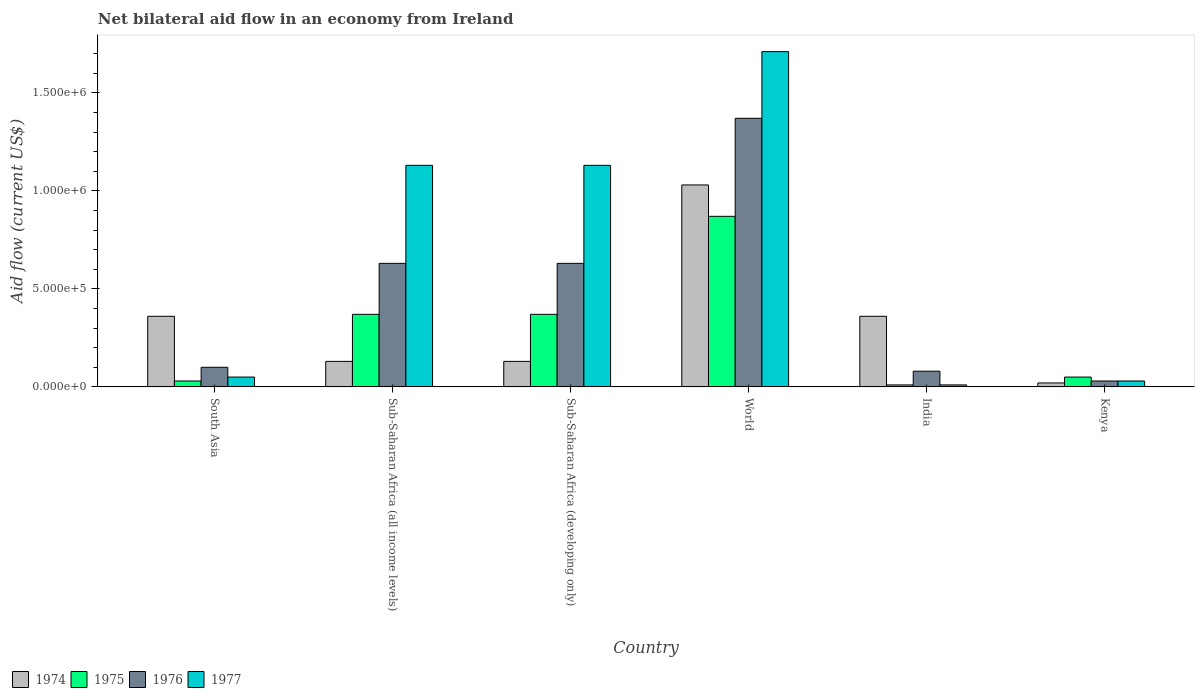How many groups of bars are there?
Provide a short and direct response. 6. Are the number of bars on each tick of the X-axis equal?
Your response must be concise. Yes. How many bars are there on the 2nd tick from the right?
Give a very brief answer. 4. What is the label of the 2nd group of bars from the left?
Give a very brief answer. Sub-Saharan Africa (all income levels). What is the net bilateral aid flow in 1977 in Sub-Saharan Africa (all income levels)?
Your response must be concise. 1.13e+06. Across all countries, what is the maximum net bilateral aid flow in 1977?
Make the answer very short. 1.71e+06. Across all countries, what is the minimum net bilateral aid flow in 1975?
Your response must be concise. 10000. In which country was the net bilateral aid flow in 1975 maximum?
Offer a terse response. World. In which country was the net bilateral aid flow in 1976 minimum?
Give a very brief answer. Kenya. What is the total net bilateral aid flow in 1976 in the graph?
Keep it short and to the point. 2.84e+06. What is the difference between the net bilateral aid flow in 1975 in India and that in Sub-Saharan Africa (developing only)?
Give a very brief answer. -3.60e+05. What is the difference between the net bilateral aid flow in 1974 in World and the net bilateral aid flow in 1976 in South Asia?
Your response must be concise. 9.30e+05. What is the average net bilateral aid flow in 1975 per country?
Give a very brief answer. 2.83e+05. What is the difference between the net bilateral aid flow of/in 1977 and net bilateral aid flow of/in 1974 in Kenya?
Keep it short and to the point. 10000. In how many countries, is the net bilateral aid flow in 1977 greater than 900000 US$?
Make the answer very short. 3. What is the ratio of the net bilateral aid flow in 1977 in Sub-Saharan Africa (developing only) to that in World?
Offer a very short reply. 0.66. Is the difference between the net bilateral aid flow in 1977 in India and Sub-Saharan Africa (all income levels) greater than the difference between the net bilateral aid flow in 1974 in India and Sub-Saharan Africa (all income levels)?
Make the answer very short. No. What is the difference between the highest and the lowest net bilateral aid flow in 1974?
Your answer should be very brief. 1.01e+06. Is the sum of the net bilateral aid flow in 1976 in Kenya and Sub-Saharan Africa (developing only) greater than the maximum net bilateral aid flow in 1977 across all countries?
Offer a terse response. No. Is it the case that in every country, the sum of the net bilateral aid flow in 1975 and net bilateral aid flow in 1977 is greater than the sum of net bilateral aid flow in 1974 and net bilateral aid flow in 1976?
Provide a short and direct response. No. What does the 1st bar from the left in Sub-Saharan Africa (all income levels) represents?
Provide a succinct answer. 1974. What does the 4th bar from the right in South Asia represents?
Offer a very short reply. 1974. Is it the case that in every country, the sum of the net bilateral aid flow in 1975 and net bilateral aid flow in 1977 is greater than the net bilateral aid flow in 1974?
Ensure brevity in your answer.  No. Are the values on the major ticks of Y-axis written in scientific E-notation?
Make the answer very short. Yes. Does the graph contain any zero values?
Offer a very short reply. No. How many legend labels are there?
Your answer should be very brief. 4. What is the title of the graph?
Keep it short and to the point. Net bilateral aid flow in an economy from Ireland. Does "1971" appear as one of the legend labels in the graph?
Keep it short and to the point. No. What is the label or title of the X-axis?
Offer a terse response. Country. What is the label or title of the Y-axis?
Ensure brevity in your answer.  Aid flow (current US$). What is the Aid flow (current US$) of 1975 in South Asia?
Offer a terse response. 3.00e+04. What is the Aid flow (current US$) in 1977 in South Asia?
Keep it short and to the point. 5.00e+04. What is the Aid flow (current US$) of 1975 in Sub-Saharan Africa (all income levels)?
Ensure brevity in your answer.  3.70e+05. What is the Aid flow (current US$) of 1976 in Sub-Saharan Africa (all income levels)?
Your response must be concise. 6.30e+05. What is the Aid flow (current US$) of 1977 in Sub-Saharan Africa (all income levels)?
Offer a very short reply. 1.13e+06. What is the Aid flow (current US$) in 1974 in Sub-Saharan Africa (developing only)?
Your answer should be compact. 1.30e+05. What is the Aid flow (current US$) of 1975 in Sub-Saharan Africa (developing only)?
Provide a short and direct response. 3.70e+05. What is the Aid flow (current US$) of 1976 in Sub-Saharan Africa (developing only)?
Your answer should be very brief. 6.30e+05. What is the Aid flow (current US$) of 1977 in Sub-Saharan Africa (developing only)?
Your response must be concise. 1.13e+06. What is the Aid flow (current US$) of 1974 in World?
Your response must be concise. 1.03e+06. What is the Aid flow (current US$) of 1975 in World?
Ensure brevity in your answer.  8.70e+05. What is the Aid flow (current US$) of 1976 in World?
Ensure brevity in your answer.  1.37e+06. What is the Aid flow (current US$) of 1977 in World?
Make the answer very short. 1.71e+06. What is the Aid flow (current US$) of 1974 in India?
Give a very brief answer. 3.60e+05. What is the Aid flow (current US$) in 1975 in India?
Provide a succinct answer. 10000. What is the Aid flow (current US$) of 1975 in Kenya?
Offer a very short reply. 5.00e+04. What is the Aid flow (current US$) in 1977 in Kenya?
Ensure brevity in your answer.  3.00e+04. Across all countries, what is the maximum Aid flow (current US$) in 1974?
Offer a terse response. 1.03e+06. Across all countries, what is the maximum Aid flow (current US$) in 1975?
Offer a terse response. 8.70e+05. Across all countries, what is the maximum Aid flow (current US$) of 1976?
Make the answer very short. 1.37e+06. Across all countries, what is the maximum Aid flow (current US$) of 1977?
Your answer should be compact. 1.71e+06. Across all countries, what is the minimum Aid flow (current US$) of 1976?
Give a very brief answer. 3.00e+04. Across all countries, what is the minimum Aid flow (current US$) in 1977?
Ensure brevity in your answer.  10000. What is the total Aid flow (current US$) in 1974 in the graph?
Provide a succinct answer. 2.03e+06. What is the total Aid flow (current US$) of 1975 in the graph?
Your response must be concise. 1.70e+06. What is the total Aid flow (current US$) of 1976 in the graph?
Keep it short and to the point. 2.84e+06. What is the total Aid flow (current US$) in 1977 in the graph?
Ensure brevity in your answer.  4.06e+06. What is the difference between the Aid flow (current US$) in 1974 in South Asia and that in Sub-Saharan Africa (all income levels)?
Your answer should be compact. 2.30e+05. What is the difference between the Aid flow (current US$) of 1976 in South Asia and that in Sub-Saharan Africa (all income levels)?
Make the answer very short. -5.30e+05. What is the difference between the Aid flow (current US$) in 1977 in South Asia and that in Sub-Saharan Africa (all income levels)?
Offer a very short reply. -1.08e+06. What is the difference between the Aid flow (current US$) of 1975 in South Asia and that in Sub-Saharan Africa (developing only)?
Make the answer very short. -3.40e+05. What is the difference between the Aid flow (current US$) in 1976 in South Asia and that in Sub-Saharan Africa (developing only)?
Your response must be concise. -5.30e+05. What is the difference between the Aid flow (current US$) in 1977 in South Asia and that in Sub-Saharan Africa (developing only)?
Provide a succinct answer. -1.08e+06. What is the difference between the Aid flow (current US$) in 1974 in South Asia and that in World?
Offer a terse response. -6.70e+05. What is the difference between the Aid flow (current US$) of 1975 in South Asia and that in World?
Provide a succinct answer. -8.40e+05. What is the difference between the Aid flow (current US$) in 1976 in South Asia and that in World?
Your response must be concise. -1.27e+06. What is the difference between the Aid flow (current US$) in 1977 in South Asia and that in World?
Provide a succinct answer. -1.66e+06. What is the difference between the Aid flow (current US$) in 1975 in South Asia and that in India?
Make the answer very short. 2.00e+04. What is the difference between the Aid flow (current US$) of 1976 in South Asia and that in India?
Your answer should be compact. 2.00e+04. What is the difference between the Aid flow (current US$) of 1977 in South Asia and that in India?
Offer a very short reply. 4.00e+04. What is the difference between the Aid flow (current US$) in 1974 in South Asia and that in Kenya?
Provide a succinct answer. 3.40e+05. What is the difference between the Aid flow (current US$) in 1975 in South Asia and that in Kenya?
Keep it short and to the point. -2.00e+04. What is the difference between the Aid flow (current US$) of 1976 in South Asia and that in Kenya?
Give a very brief answer. 7.00e+04. What is the difference between the Aid flow (current US$) of 1974 in Sub-Saharan Africa (all income levels) and that in Sub-Saharan Africa (developing only)?
Offer a very short reply. 0. What is the difference between the Aid flow (current US$) in 1975 in Sub-Saharan Africa (all income levels) and that in Sub-Saharan Africa (developing only)?
Ensure brevity in your answer.  0. What is the difference between the Aid flow (current US$) in 1977 in Sub-Saharan Africa (all income levels) and that in Sub-Saharan Africa (developing only)?
Ensure brevity in your answer.  0. What is the difference between the Aid flow (current US$) of 1974 in Sub-Saharan Africa (all income levels) and that in World?
Make the answer very short. -9.00e+05. What is the difference between the Aid flow (current US$) in 1975 in Sub-Saharan Africa (all income levels) and that in World?
Your answer should be very brief. -5.00e+05. What is the difference between the Aid flow (current US$) of 1976 in Sub-Saharan Africa (all income levels) and that in World?
Your response must be concise. -7.40e+05. What is the difference between the Aid flow (current US$) of 1977 in Sub-Saharan Africa (all income levels) and that in World?
Provide a short and direct response. -5.80e+05. What is the difference between the Aid flow (current US$) of 1974 in Sub-Saharan Africa (all income levels) and that in India?
Make the answer very short. -2.30e+05. What is the difference between the Aid flow (current US$) in 1977 in Sub-Saharan Africa (all income levels) and that in India?
Your answer should be very brief. 1.12e+06. What is the difference between the Aid flow (current US$) in 1977 in Sub-Saharan Africa (all income levels) and that in Kenya?
Provide a short and direct response. 1.10e+06. What is the difference between the Aid flow (current US$) of 1974 in Sub-Saharan Africa (developing only) and that in World?
Ensure brevity in your answer.  -9.00e+05. What is the difference between the Aid flow (current US$) in 1975 in Sub-Saharan Africa (developing only) and that in World?
Your answer should be very brief. -5.00e+05. What is the difference between the Aid flow (current US$) in 1976 in Sub-Saharan Africa (developing only) and that in World?
Provide a succinct answer. -7.40e+05. What is the difference between the Aid flow (current US$) in 1977 in Sub-Saharan Africa (developing only) and that in World?
Ensure brevity in your answer.  -5.80e+05. What is the difference between the Aid flow (current US$) of 1974 in Sub-Saharan Africa (developing only) and that in India?
Provide a succinct answer. -2.30e+05. What is the difference between the Aid flow (current US$) of 1975 in Sub-Saharan Africa (developing only) and that in India?
Give a very brief answer. 3.60e+05. What is the difference between the Aid flow (current US$) of 1976 in Sub-Saharan Africa (developing only) and that in India?
Your answer should be compact. 5.50e+05. What is the difference between the Aid flow (current US$) of 1977 in Sub-Saharan Africa (developing only) and that in India?
Offer a very short reply. 1.12e+06. What is the difference between the Aid flow (current US$) of 1974 in Sub-Saharan Africa (developing only) and that in Kenya?
Offer a terse response. 1.10e+05. What is the difference between the Aid flow (current US$) of 1976 in Sub-Saharan Africa (developing only) and that in Kenya?
Make the answer very short. 6.00e+05. What is the difference between the Aid flow (current US$) of 1977 in Sub-Saharan Africa (developing only) and that in Kenya?
Offer a terse response. 1.10e+06. What is the difference between the Aid flow (current US$) in 1974 in World and that in India?
Offer a very short reply. 6.70e+05. What is the difference between the Aid flow (current US$) of 1975 in World and that in India?
Provide a succinct answer. 8.60e+05. What is the difference between the Aid flow (current US$) of 1976 in World and that in India?
Provide a short and direct response. 1.29e+06. What is the difference between the Aid flow (current US$) in 1977 in World and that in India?
Your answer should be very brief. 1.70e+06. What is the difference between the Aid flow (current US$) of 1974 in World and that in Kenya?
Offer a terse response. 1.01e+06. What is the difference between the Aid flow (current US$) of 1975 in World and that in Kenya?
Provide a succinct answer. 8.20e+05. What is the difference between the Aid flow (current US$) in 1976 in World and that in Kenya?
Make the answer very short. 1.34e+06. What is the difference between the Aid flow (current US$) in 1977 in World and that in Kenya?
Your answer should be compact. 1.68e+06. What is the difference between the Aid flow (current US$) of 1974 in India and that in Kenya?
Make the answer very short. 3.40e+05. What is the difference between the Aid flow (current US$) in 1975 in India and that in Kenya?
Your answer should be very brief. -4.00e+04. What is the difference between the Aid flow (current US$) in 1976 in India and that in Kenya?
Offer a very short reply. 5.00e+04. What is the difference between the Aid flow (current US$) in 1977 in India and that in Kenya?
Your response must be concise. -2.00e+04. What is the difference between the Aid flow (current US$) of 1974 in South Asia and the Aid flow (current US$) of 1975 in Sub-Saharan Africa (all income levels)?
Your response must be concise. -10000. What is the difference between the Aid flow (current US$) in 1974 in South Asia and the Aid flow (current US$) in 1976 in Sub-Saharan Africa (all income levels)?
Keep it short and to the point. -2.70e+05. What is the difference between the Aid flow (current US$) in 1974 in South Asia and the Aid flow (current US$) in 1977 in Sub-Saharan Africa (all income levels)?
Your answer should be very brief. -7.70e+05. What is the difference between the Aid flow (current US$) in 1975 in South Asia and the Aid flow (current US$) in 1976 in Sub-Saharan Africa (all income levels)?
Your answer should be very brief. -6.00e+05. What is the difference between the Aid flow (current US$) in 1975 in South Asia and the Aid flow (current US$) in 1977 in Sub-Saharan Africa (all income levels)?
Make the answer very short. -1.10e+06. What is the difference between the Aid flow (current US$) in 1976 in South Asia and the Aid flow (current US$) in 1977 in Sub-Saharan Africa (all income levels)?
Ensure brevity in your answer.  -1.03e+06. What is the difference between the Aid flow (current US$) in 1974 in South Asia and the Aid flow (current US$) in 1976 in Sub-Saharan Africa (developing only)?
Your response must be concise. -2.70e+05. What is the difference between the Aid flow (current US$) in 1974 in South Asia and the Aid flow (current US$) in 1977 in Sub-Saharan Africa (developing only)?
Provide a succinct answer. -7.70e+05. What is the difference between the Aid flow (current US$) of 1975 in South Asia and the Aid flow (current US$) of 1976 in Sub-Saharan Africa (developing only)?
Your answer should be very brief. -6.00e+05. What is the difference between the Aid flow (current US$) of 1975 in South Asia and the Aid flow (current US$) of 1977 in Sub-Saharan Africa (developing only)?
Provide a short and direct response. -1.10e+06. What is the difference between the Aid flow (current US$) of 1976 in South Asia and the Aid flow (current US$) of 1977 in Sub-Saharan Africa (developing only)?
Your response must be concise. -1.03e+06. What is the difference between the Aid flow (current US$) of 1974 in South Asia and the Aid flow (current US$) of 1975 in World?
Your response must be concise. -5.10e+05. What is the difference between the Aid flow (current US$) of 1974 in South Asia and the Aid flow (current US$) of 1976 in World?
Offer a terse response. -1.01e+06. What is the difference between the Aid flow (current US$) in 1974 in South Asia and the Aid flow (current US$) in 1977 in World?
Offer a terse response. -1.35e+06. What is the difference between the Aid flow (current US$) of 1975 in South Asia and the Aid flow (current US$) of 1976 in World?
Offer a terse response. -1.34e+06. What is the difference between the Aid flow (current US$) in 1975 in South Asia and the Aid flow (current US$) in 1977 in World?
Ensure brevity in your answer.  -1.68e+06. What is the difference between the Aid flow (current US$) in 1976 in South Asia and the Aid flow (current US$) in 1977 in World?
Keep it short and to the point. -1.61e+06. What is the difference between the Aid flow (current US$) of 1975 in South Asia and the Aid flow (current US$) of 1977 in India?
Provide a succinct answer. 2.00e+04. What is the difference between the Aid flow (current US$) in 1976 in South Asia and the Aid flow (current US$) in 1977 in India?
Your answer should be very brief. 9.00e+04. What is the difference between the Aid flow (current US$) of 1974 in South Asia and the Aid flow (current US$) of 1976 in Kenya?
Ensure brevity in your answer.  3.30e+05. What is the difference between the Aid flow (current US$) in 1974 in South Asia and the Aid flow (current US$) in 1977 in Kenya?
Your answer should be very brief. 3.30e+05. What is the difference between the Aid flow (current US$) of 1976 in South Asia and the Aid flow (current US$) of 1977 in Kenya?
Ensure brevity in your answer.  7.00e+04. What is the difference between the Aid flow (current US$) of 1974 in Sub-Saharan Africa (all income levels) and the Aid flow (current US$) of 1975 in Sub-Saharan Africa (developing only)?
Provide a short and direct response. -2.40e+05. What is the difference between the Aid flow (current US$) of 1974 in Sub-Saharan Africa (all income levels) and the Aid flow (current US$) of 1976 in Sub-Saharan Africa (developing only)?
Your answer should be compact. -5.00e+05. What is the difference between the Aid flow (current US$) in 1975 in Sub-Saharan Africa (all income levels) and the Aid flow (current US$) in 1976 in Sub-Saharan Africa (developing only)?
Make the answer very short. -2.60e+05. What is the difference between the Aid flow (current US$) of 1975 in Sub-Saharan Africa (all income levels) and the Aid flow (current US$) of 1977 in Sub-Saharan Africa (developing only)?
Offer a terse response. -7.60e+05. What is the difference between the Aid flow (current US$) of 1976 in Sub-Saharan Africa (all income levels) and the Aid flow (current US$) of 1977 in Sub-Saharan Africa (developing only)?
Offer a very short reply. -5.00e+05. What is the difference between the Aid flow (current US$) of 1974 in Sub-Saharan Africa (all income levels) and the Aid flow (current US$) of 1975 in World?
Ensure brevity in your answer.  -7.40e+05. What is the difference between the Aid flow (current US$) of 1974 in Sub-Saharan Africa (all income levels) and the Aid flow (current US$) of 1976 in World?
Your answer should be compact. -1.24e+06. What is the difference between the Aid flow (current US$) in 1974 in Sub-Saharan Africa (all income levels) and the Aid flow (current US$) in 1977 in World?
Offer a very short reply. -1.58e+06. What is the difference between the Aid flow (current US$) in 1975 in Sub-Saharan Africa (all income levels) and the Aid flow (current US$) in 1976 in World?
Keep it short and to the point. -1.00e+06. What is the difference between the Aid flow (current US$) of 1975 in Sub-Saharan Africa (all income levels) and the Aid flow (current US$) of 1977 in World?
Your answer should be very brief. -1.34e+06. What is the difference between the Aid flow (current US$) in 1976 in Sub-Saharan Africa (all income levels) and the Aid flow (current US$) in 1977 in World?
Offer a terse response. -1.08e+06. What is the difference between the Aid flow (current US$) of 1974 in Sub-Saharan Africa (all income levels) and the Aid flow (current US$) of 1975 in India?
Your answer should be compact. 1.20e+05. What is the difference between the Aid flow (current US$) in 1974 in Sub-Saharan Africa (all income levels) and the Aid flow (current US$) in 1977 in India?
Your answer should be very brief. 1.20e+05. What is the difference between the Aid flow (current US$) of 1975 in Sub-Saharan Africa (all income levels) and the Aid flow (current US$) of 1976 in India?
Provide a succinct answer. 2.90e+05. What is the difference between the Aid flow (current US$) of 1975 in Sub-Saharan Africa (all income levels) and the Aid flow (current US$) of 1977 in India?
Your response must be concise. 3.60e+05. What is the difference between the Aid flow (current US$) in 1976 in Sub-Saharan Africa (all income levels) and the Aid flow (current US$) in 1977 in India?
Keep it short and to the point. 6.20e+05. What is the difference between the Aid flow (current US$) in 1974 in Sub-Saharan Africa (all income levels) and the Aid flow (current US$) in 1976 in Kenya?
Provide a succinct answer. 1.00e+05. What is the difference between the Aid flow (current US$) in 1975 in Sub-Saharan Africa (all income levels) and the Aid flow (current US$) in 1976 in Kenya?
Make the answer very short. 3.40e+05. What is the difference between the Aid flow (current US$) of 1976 in Sub-Saharan Africa (all income levels) and the Aid flow (current US$) of 1977 in Kenya?
Make the answer very short. 6.00e+05. What is the difference between the Aid flow (current US$) in 1974 in Sub-Saharan Africa (developing only) and the Aid flow (current US$) in 1975 in World?
Make the answer very short. -7.40e+05. What is the difference between the Aid flow (current US$) in 1974 in Sub-Saharan Africa (developing only) and the Aid flow (current US$) in 1976 in World?
Your answer should be very brief. -1.24e+06. What is the difference between the Aid flow (current US$) of 1974 in Sub-Saharan Africa (developing only) and the Aid flow (current US$) of 1977 in World?
Provide a short and direct response. -1.58e+06. What is the difference between the Aid flow (current US$) in 1975 in Sub-Saharan Africa (developing only) and the Aid flow (current US$) in 1976 in World?
Offer a terse response. -1.00e+06. What is the difference between the Aid flow (current US$) of 1975 in Sub-Saharan Africa (developing only) and the Aid flow (current US$) of 1977 in World?
Make the answer very short. -1.34e+06. What is the difference between the Aid flow (current US$) of 1976 in Sub-Saharan Africa (developing only) and the Aid flow (current US$) of 1977 in World?
Your answer should be very brief. -1.08e+06. What is the difference between the Aid flow (current US$) of 1974 in Sub-Saharan Africa (developing only) and the Aid flow (current US$) of 1975 in India?
Provide a short and direct response. 1.20e+05. What is the difference between the Aid flow (current US$) in 1974 in Sub-Saharan Africa (developing only) and the Aid flow (current US$) in 1976 in India?
Make the answer very short. 5.00e+04. What is the difference between the Aid flow (current US$) of 1975 in Sub-Saharan Africa (developing only) and the Aid flow (current US$) of 1976 in India?
Provide a short and direct response. 2.90e+05. What is the difference between the Aid flow (current US$) of 1976 in Sub-Saharan Africa (developing only) and the Aid flow (current US$) of 1977 in India?
Provide a succinct answer. 6.20e+05. What is the difference between the Aid flow (current US$) in 1974 in Sub-Saharan Africa (developing only) and the Aid flow (current US$) in 1976 in Kenya?
Provide a succinct answer. 1.00e+05. What is the difference between the Aid flow (current US$) in 1974 in Sub-Saharan Africa (developing only) and the Aid flow (current US$) in 1977 in Kenya?
Your response must be concise. 1.00e+05. What is the difference between the Aid flow (current US$) in 1974 in World and the Aid flow (current US$) in 1975 in India?
Offer a very short reply. 1.02e+06. What is the difference between the Aid flow (current US$) of 1974 in World and the Aid flow (current US$) of 1976 in India?
Provide a succinct answer. 9.50e+05. What is the difference between the Aid flow (current US$) of 1974 in World and the Aid flow (current US$) of 1977 in India?
Provide a short and direct response. 1.02e+06. What is the difference between the Aid flow (current US$) in 1975 in World and the Aid flow (current US$) in 1976 in India?
Your answer should be very brief. 7.90e+05. What is the difference between the Aid flow (current US$) of 1975 in World and the Aid flow (current US$) of 1977 in India?
Offer a very short reply. 8.60e+05. What is the difference between the Aid flow (current US$) in 1976 in World and the Aid flow (current US$) in 1977 in India?
Provide a short and direct response. 1.36e+06. What is the difference between the Aid flow (current US$) of 1974 in World and the Aid flow (current US$) of 1975 in Kenya?
Your answer should be compact. 9.80e+05. What is the difference between the Aid flow (current US$) of 1974 in World and the Aid flow (current US$) of 1976 in Kenya?
Offer a terse response. 1.00e+06. What is the difference between the Aid flow (current US$) in 1974 in World and the Aid flow (current US$) in 1977 in Kenya?
Ensure brevity in your answer.  1.00e+06. What is the difference between the Aid flow (current US$) in 1975 in World and the Aid flow (current US$) in 1976 in Kenya?
Your answer should be compact. 8.40e+05. What is the difference between the Aid flow (current US$) of 1975 in World and the Aid flow (current US$) of 1977 in Kenya?
Your answer should be very brief. 8.40e+05. What is the difference between the Aid flow (current US$) in 1976 in World and the Aid flow (current US$) in 1977 in Kenya?
Provide a succinct answer. 1.34e+06. What is the difference between the Aid flow (current US$) of 1974 in India and the Aid flow (current US$) of 1975 in Kenya?
Ensure brevity in your answer.  3.10e+05. What is the difference between the Aid flow (current US$) of 1974 in India and the Aid flow (current US$) of 1976 in Kenya?
Offer a terse response. 3.30e+05. What is the difference between the Aid flow (current US$) in 1974 in India and the Aid flow (current US$) in 1977 in Kenya?
Keep it short and to the point. 3.30e+05. What is the difference between the Aid flow (current US$) in 1975 in India and the Aid flow (current US$) in 1976 in Kenya?
Offer a very short reply. -2.00e+04. What is the average Aid flow (current US$) in 1974 per country?
Your answer should be very brief. 3.38e+05. What is the average Aid flow (current US$) of 1975 per country?
Your response must be concise. 2.83e+05. What is the average Aid flow (current US$) of 1976 per country?
Your answer should be compact. 4.73e+05. What is the average Aid flow (current US$) in 1977 per country?
Provide a succinct answer. 6.77e+05. What is the difference between the Aid flow (current US$) in 1974 and Aid flow (current US$) in 1975 in South Asia?
Keep it short and to the point. 3.30e+05. What is the difference between the Aid flow (current US$) of 1974 and Aid flow (current US$) of 1977 in South Asia?
Your response must be concise. 3.10e+05. What is the difference between the Aid flow (current US$) in 1975 and Aid flow (current US$) in 1977 in South Asia?
Provide a succinct answer. -2.00e+04. What is the difference between the Aid flow (current US$) in 1976 and Aid flow (current US$) in 1977 in South Asia?
Give a very brief answer. 5.00e+04. What is the difference between the Aid flow (current US$) in 1974 and Aid flow (current US$) in 1975 in Sub-Saharan Africa (all income levels)?
Offer a terse response. -2.40e+05. What is the difference between the Aid flow (current US$) of 1974 and Aid flow (current US$) of 1976 in Sub-Saharan Africa (all income levels)?
Make the answer very short. -5.00e+05. What is the difference between the Aid flow (current US$) in 1974 and Aid flow (current US$) in 1977 in Sub-Saharan Africa (all income levels)?
Keep it short and to the point. -1.00e+06. What is the difference between the Aid flow (current US$) in 1975 and Aid flow (current US$) in 1976 in Sub-Saharan Africa (all income levels)?
Make the answer very short. -2.60e+05. What is the difference between the Aid flow (current US$) of 1975 and Aid flow (current US$) of 1977 in Sub-Saharan Africa (all income levels)?
Your response must be concise. -7.60e+05. What is the difference between the Aid flow (current US$) in 1976 and Aid flow (current US$) in 1977 in Sub-Saharan Africa (all income levels)?
Keep it short and to the point. -5.00e+05. What is the difference between the Aid flow (current US$) of 1974 and Aid flow (current US$) of 1976 in Sub-Saharan Africa (developing only)?
Keep it short and to the point. -5.00e+05. What is the difference between the Aid flow (current US$) in 1974 and Aid flow (current US$) in 1977 in Sub-Saharan Africa (developing only)?
Make the answer very short. -1.00e+06. What is the difference between the Aid flow (current US$) of 1975 and Aid flow (current US$) of 1977 in Sub-Saharan Africa (developing only)?
Offer a terse response. -7.60e+05. What is the difference between the Aid flow (current US$) in 1976 and Aid flow (current US$) in 1977 in Sub-Saharan Africa (developing only)?
Ensure brevity in your answer.  -5.00e+05. What is the difference between the Aid flow (current US$) of 1974 and Aid flow (current US$) of 1977 in World?
Make the answer very short. -6.80e+05. What is the difference between the Aid flow (current US$) in 1975 and Aid flow (current US$) in 1976 in World?
Keep it short and to the point. -5.00e+05. What is the difference between the Aid flow (current US$) of 1975 and Aid flow (current US$) of 1977 in World?
Make the answer very short. -8.40e+05. What is the difference between the Aid flow (current US$) of 1974 and Aid flow (current US$) of 1975 in India?
Give a very brief answer. 3.50e+05. What is the difference between the Aid flow (current US$) in 1974 and Aid flow (current US$) in 1977 in India?
Ensure brevity in your answer.  3.50e+05. What is the difference between the Aid flow (current US$) of 1975 and Aid flow (current US$) of 1976 in India?
Ensure brevity in your answer.  -7.00e+04. What is the difference between the Aid flow (current US$) in 1974 and Aid flow (current US$) in 1976 in Kenya?
Keep it short and to the point. -10000. What is the difference between the Aid flow (current US$) of 1974 and Aid flow (current US$) of 1977 in Kenya?
Your answer should be very brief. -10000. What is the ratio of the Aid flow (current US$) of 1974 in South Asia to that in Sub-Saharan Africa (all income levels)?
Keep it short and to the point. 2.77. What is the ratio of the Aid flow (current US$) of 1975 in South Asia to that in Sub-Saharan Africa (all income levels)?
Provide a short and direct response. 0.08. What is the ratio of the Aid flow (current US$) in 1976 in South Asia to that in Sub-Saharan Africa (all income levels)?
Provide a succinct answer. 0.16. What is the ratio of the Aid flow (current US$) of 1977 in South Asia to that in Sub-Saharan Africa (all income levels)?
Your answer should be very brief. 0.04. What is the ratio of the Aid flow (current US$) in 1974 in South Asia to that in Sub-Saharan Africa (developing only)?
Give a very brief answer. 2.77. What is the ratio of the Aid flow (current US$) in 1975 in South Asia to that in Sub-Saharan Africa (developing only)?
Provide a short and direct response. 0.08. What is the ratio of the Aid flow (current US$) of 1976 in South Asia to that in Sub-Saharan Africa (developing only)?
Ensure brevity in your answer.  0.16. What is the ratio of the Aid flow (current US$) in 1977 in South Asia to that in Sub-Saharan Africa (developing only)?
Offer a terse response. 0.04. What is the ratio of the Aid flow (current US$) of 1974 in South Asia to that in World?
Offer a very short reply. 0.35. What is the ratio of the Aid flow (current US$) in 1975 in South Asia to that in World?
Provide a succinct answer. 0.03. What is the ratio of the Aid flow (current US$) in 1976 in South Asia to that in World?
Provide a succinct answer. 0.07. What is the ratio of the Aid flow (current US$) in 1977 in South Asia to that in World?
Your answer should be very brief. 0.03. What is the ratio of the Aid flow (current US$) in 1975 in South Asia to that in India?
Make the answer very short. 3. What is the ratio of the Aid flow (current US$) of 1976 in South Asia to that in Kenya?
Provide a succinct answer. 3.33. What is the ratio of the Aid flow (current US$) in 1977 in South Asia to that in Kenya?
Offer a very short reply. 1.67. What is the ratio of the Aid flow (current US$) of 1974 in Sub-Saharan Africa (all income levels) to that in Sub-Saharan Africa (developing only)?
Give a very brief answer. 1. What is the ratio of the Aid flow (current US$) of 1975 in Sub-Saharan Africa (all income levels) to that in Sub-Saharan Africa (developing only)?
Offer a very short reply. 1. What is the ratio of the Aid flow (current US$) in 1976 in Sub-Saharan Africa (all income levels) to that in Sub-Saharan Africa (developing only)?
Your answer should be compact. 1. What is the ratio of the Aid flow (current US$) of 1977 in Sub-Saharan Africa (all income levels) to that in Sub-Saharan Africa (developing only)?
Give a very brief answer. 1. What is the ratio of the Aid flow (current US$) of 1974 in Sub-Saharan Africa (all income levels) to that in World?
Your answer should be compact. 0.13. What is the ratio of the Aid flow (current US$) of 1975 in Sub-Saharan Africa (all income levels) to that in World?
Your answer should be compact. 0.43. What is the ratio of the Aid flow (current US$) in 1976 in Sub-Saharan Africa (all income levels) to that in World?
Your response must be concise. 0.46. What is the ratio of the Aid flow (current US$) in 1977 in Sub-Saharan Africa (all income levels) to that in World?
Your answer should be very brief. 0.66. What is the ratio of the Aid flow (current US$) in 1974 in Sub-Saharan Africa (all income levels) to that in India?
Keep it short and to the point. 0.36. What is the ratio of the Aid flow (current US$) in 1976 in Sub-Saharan Africa (all income levels) to that in India?
Give a very brief answer. 7.88. What is the ratio of the Aid flow (current US$) of 1977 in Sub-Saharan Africa (all income levels) to that in India?
Ensure brevity in your answer.  113. What is the ratio of the Aid flow (current US$) of 1974 in Sub-Saharan Africa (all income levels) to that in Kenya?
Keep it short and to the point. 6.5. What is the ratio of the Aid flow (current US$) in 1976 in Sub-Saharan Africa (all income levels) to that in Kenya?
Provide a succinct answer. 21. What is the ratio of the Aid flow (current US$) in 1977 in Sub-Saharan Africa (all income levels) to that in Kenya?
Give a very brief answer. 37.67. What is the ratio of the Aid flow (current US$) of 1974 in Sub-Saharan Africa (developing only) to that in World?
Offer a terse response. 0.13. What is the ratio of the Aid flow (current US$) of 1975 in Sub-Saharan Africa (developing only) to that in World?
Ensure brevity in your answer.  0.43. What is the ratio of the Aid flow (current US$) in 1976 in Sub-Saharan Africa (developing only) to that in World?
Give a very brief answer. 0.46. What is the ratio of the Aid flow (current US$) of 1977 in Sub-Saharan Africa (developing only) to that in World?
Offer a terse response. 0.66. What is the ratio of the Aid flow (current US$) in 1974 in Sub-Saharan Africa (developing only) to that in India?
Provide a short and direct response. 0.36. What is the ratio of the Aid flow (current US$) of 1975 in Sub-Saharan Africa (developing only) to that in India?
Your response must be concise. 37. What is the ratio of the Aid flow (current US$) in 1976 in Sub-Saharan Africa (developing only) to that in India?
Your response must be concise. 7.88. What is the ratio of the Aid flow (current US$) of 1977 in Sub-Saharan Africa (developing only) to that in India?
Make the answer very short. 113. What is the ratio of the Aid flow (current US$) of 1975 in Sub-Saharan Africa (developing only) to that in Kenya?
Give a very brief answer. 7.4. What is the ratio of the Aid flow (current US$) in 1977 in Sub-Saharan Africa (developing only) to that in Kenya?
Your answer should be very brief. 37.67. What is the ratio of the Aid flow (current US$) in 1974 in World to that in India?
Make the answer very short. 2.86. What is the ratio of the Aid flow (current US$) of 1976 in World to that in India?
Keep it short and to the point. 17.12. What is the ratio of the Aid flow (current US$) in 1977 in World to that in India?
Your answer should be very brief. 171. What is the ratio of the Aid flow (current US$) of 1974 in World to that in Kenya?
Make the answer very short. 51.5. What is the ratio of the Aid flow (current US$) of 1976 in World to that in Kenya?
Provide a short and direct response. 45.67. What is the ratio of the Aid flow (current US$) in 1977 in World to that in Kenya?
Provide a succinct answer. 57. What is the ratio of the Aid flow (current US$) in 1975 in India to that in Kenya?
Make the answer very short. 0.2. What is the ratio of the Aid flow (current US$) in 1976 in India to that in Kenya?
Your answer should be compact. 2.67. What is the difference between the highest and the second highest Aid flow (current US$) in 1974?
Make the answer very short. 6.70e+05. What is the difference between the highest and the second highest Aid flow (current US$) in 1976?
Give a very brief answer. 7.40e+05. What is the difference between the highest and the second highest Aid flow (current US$) of 1977?
Make the answer very short. 5.80e+05. What is the difference between the highest and the lowest Aid flow (current US$) of 1974?
Make the answer very short. 1.01e+06. What is the difference between the highest and the lowest Aid flow (current US$) in 1975?
Offer a terse response. 8.60e+05. What is the difference between the highest and the lowest Aid flow (current US$) of 1976?
Your response must be concise. 1.34e+06. What is the difference between the highest and the lowest Aid flow (current US$) of 1977?
Keep it short and to the point. 1.70e+06. 